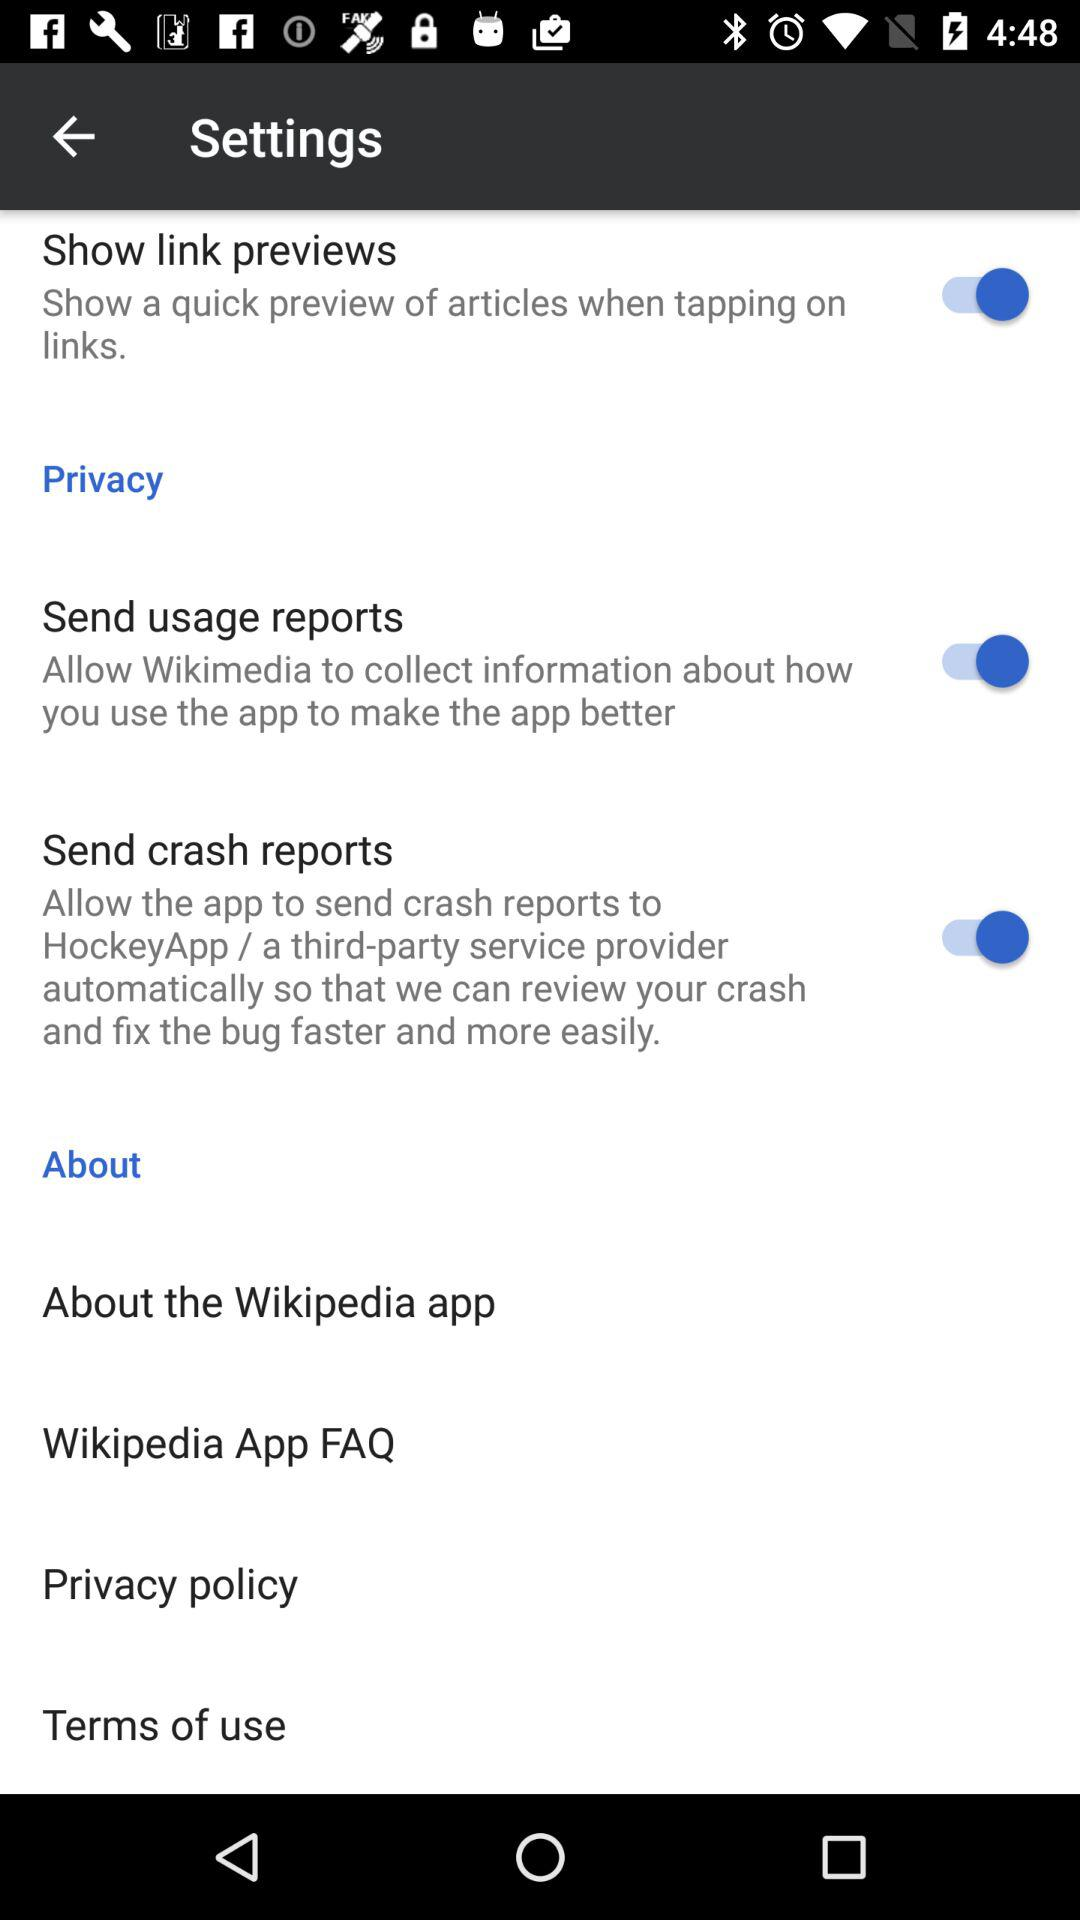How many items are in the privacy section?
Answer the question using a single word or phrase. 2 